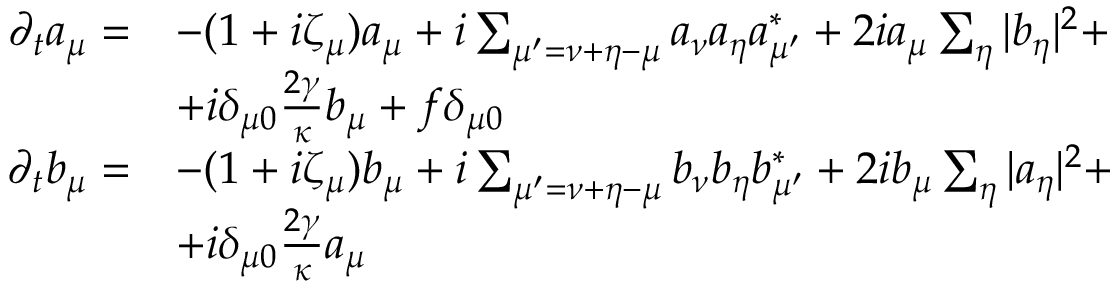<formula> <loc_0><loc_0><loc_500><loc_500>\begin{array} { r l } { \partial _ { t } a _ { \mu } = } & { - ( 1 + i \zeta _ { \mu } ) a _ { \mu } + i \sum _ { \mu ^ { \prime } = \nu + \eta - \mu } a _ { \nu } a _ { \eta } a _ { \mu ^ { \prime } } ^ { * } + 2 i a _ { \mu } \sum _ { \eta } | b _ { \eta } | ^ { 2 } + } \\ & { + i \delta _ { \mu 0 } \frac { 2 \gamma } { \kappa } b _ { \mu } + f \delta _ { \mu 0 } } \\ { \partial _ { t } b _ { \mu } = } & { - ( 1 + i \zeta _ { \mu } ) b _ { \mu } + i \sum _ { \mu ^ { \prime } = \nu + \eta - \mu } b _ { \nu } b _ { \eta } b _ { \mu ^ { \prime } } ^ { * } + 2 i b _ { \mu } \sum _ { \eta } | a _ { \eta } | ^ { 2 } + } \\ & { + i \delta _ { \mu 0 } \frac { 2 \gamma } { \kappa } a _ { \mu } } \end{array}</formula> 